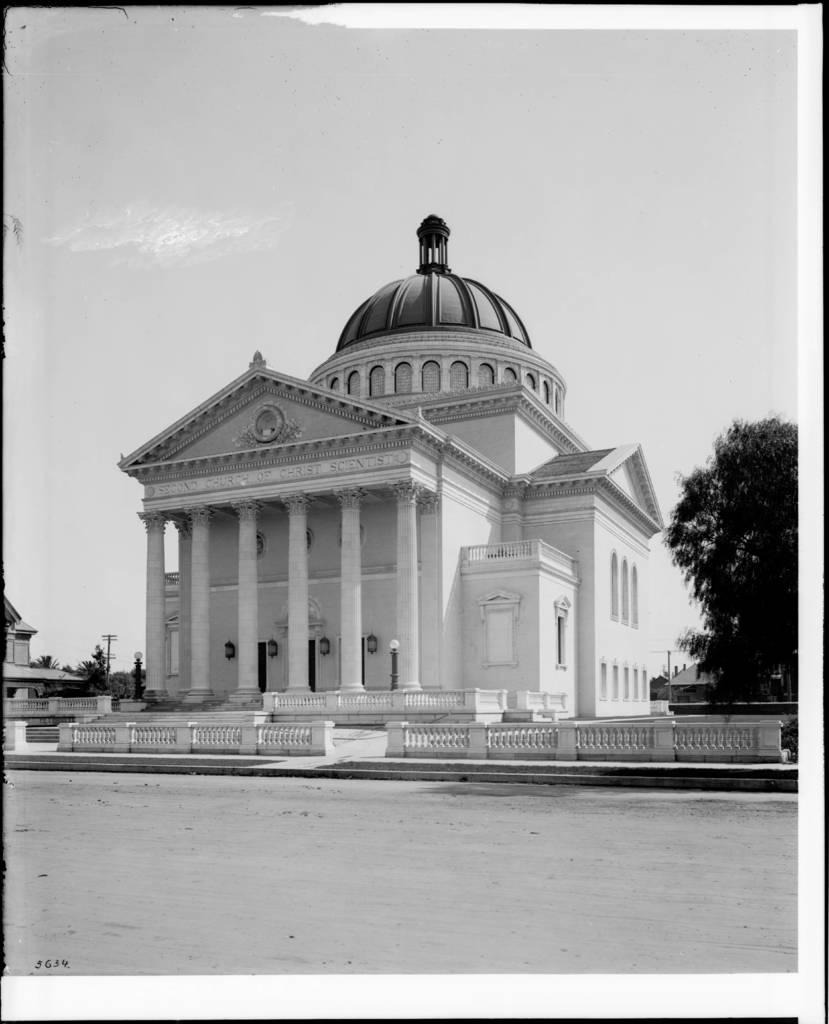What is the main structure in the image? There is a white building in the image. What is the setting of the white building? The white building is surrounded by trees. Are there any other buildings in the image? Yes, there are other houses in the image. What type of mint is growing on the chin of the person in the image? There is no person present in the image, and therefore no chin or mint can be observed. 